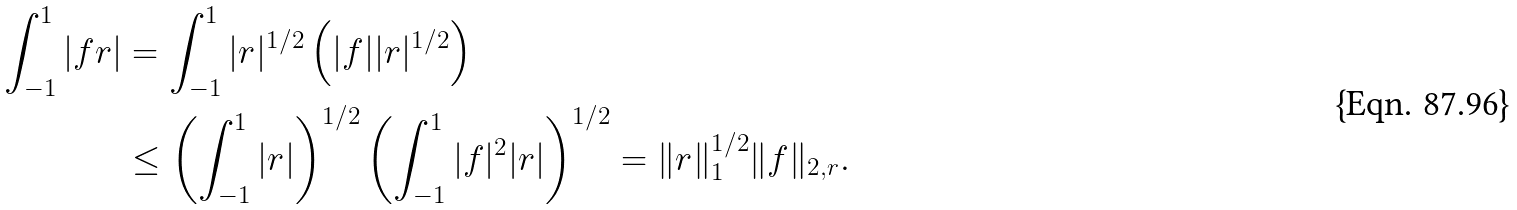Convert formula to latex. <formula><loc_0><loc_0><loc_500><loc_500>\int _ { - 1 } ^ { 1 } | f r | & = \int _ { - 1 } ^ { 1 } | r | ^ { 1 / 2 } \left ( | f | | r | ^ { 1 / 2 } \right ) \\ & \leq \left ( \int _ { - 1 } ^ { 1 } | r | \right ) ^ { 1 / 2 } \left ( \int _ { - 1 } ^ { 1 } | f | ^ { 2 } | r | \right ) ^ { 1 / 2 } = \| r \| _ { 1 } ^ { 1 / 2 } \| f \| _ { 2 , r } .</formula> 